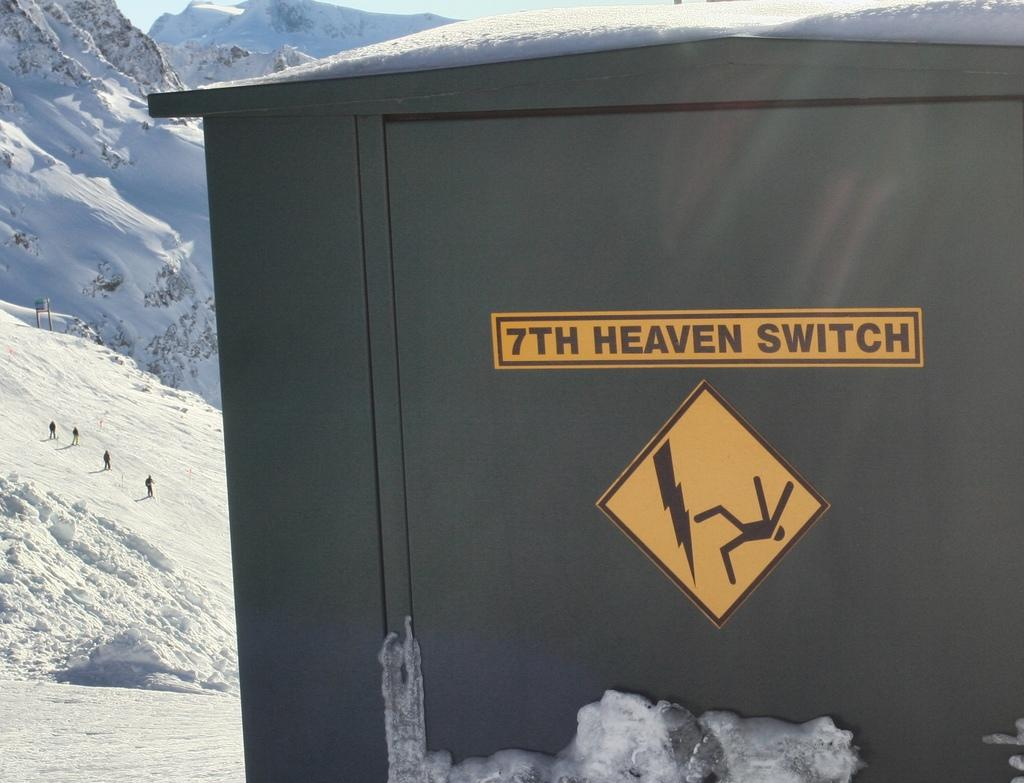<image>
Give a short and clear explanation of the subsequent image. A gray box says "7TH HEAVEN SWITCH" on the front. 